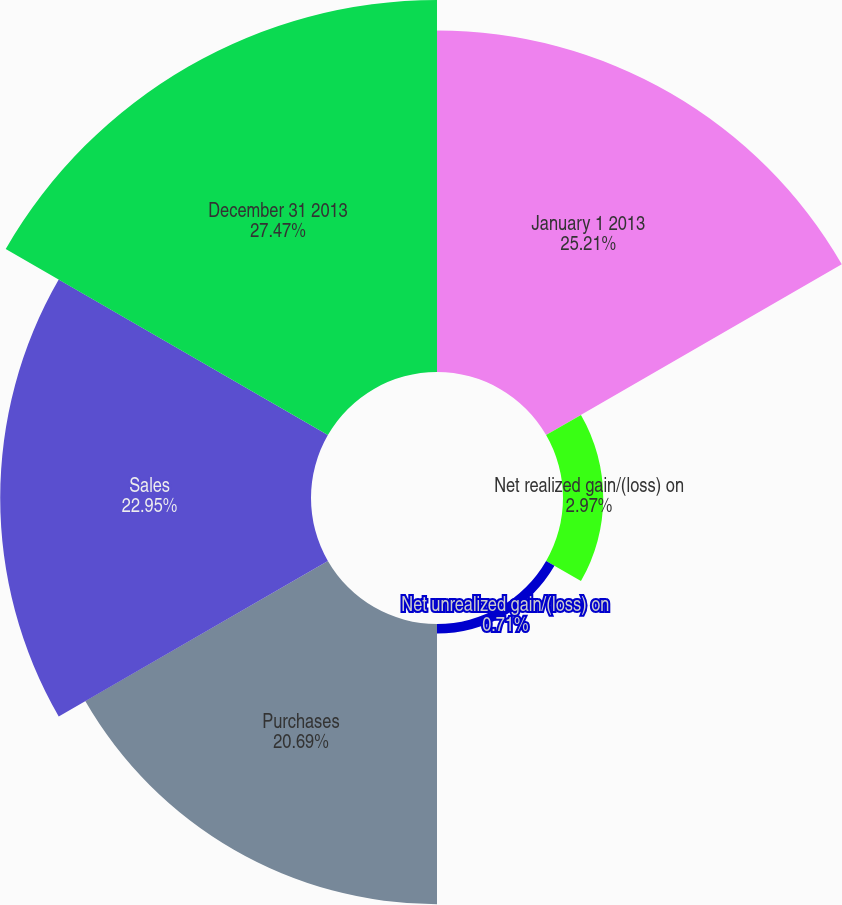Convert chart. <chart><loc_0><loc_0><loc_500><loc_500><pie_chart><fcel>January 1 2013<fcel>Net realized gain/(loss) on<fcel>Net unrealized gain/(loss) on<fcel>Purchases<fcel>Sales<fcel>December 31 2013<nl><fcel>25.21%<fcel>2.97%<fcel>0.71%<fcel>20.69%<fcel>22.95%<fcel>27.47%<nl></chart> 